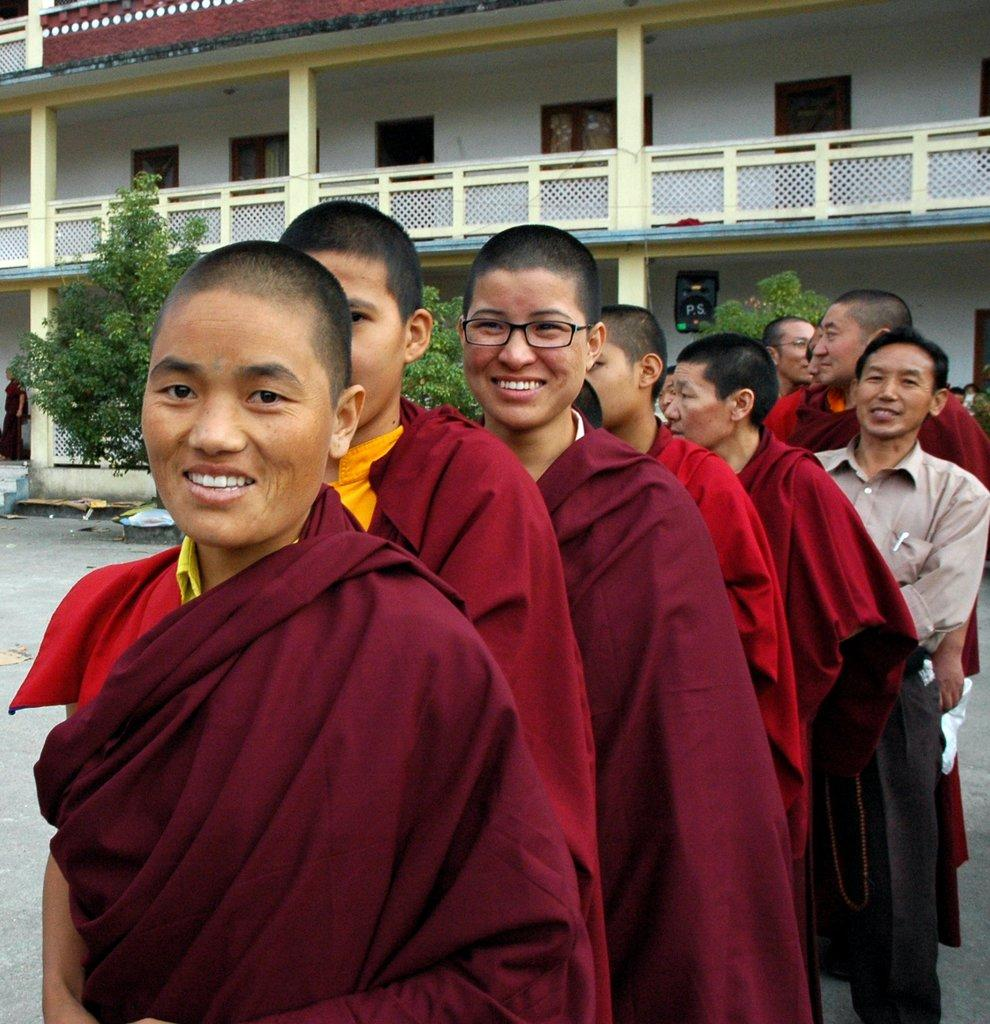What is happening with the group of people in the image? The group of people is standing in a row. What can be seen in the background of the image? There is a building with windows, a person standing under a roof, and a group of plants in the background. What type of hook is being used by the person standing under the roof in the image? There is no hook visible in the image; the person standing under the roof is not using any tool or object. 